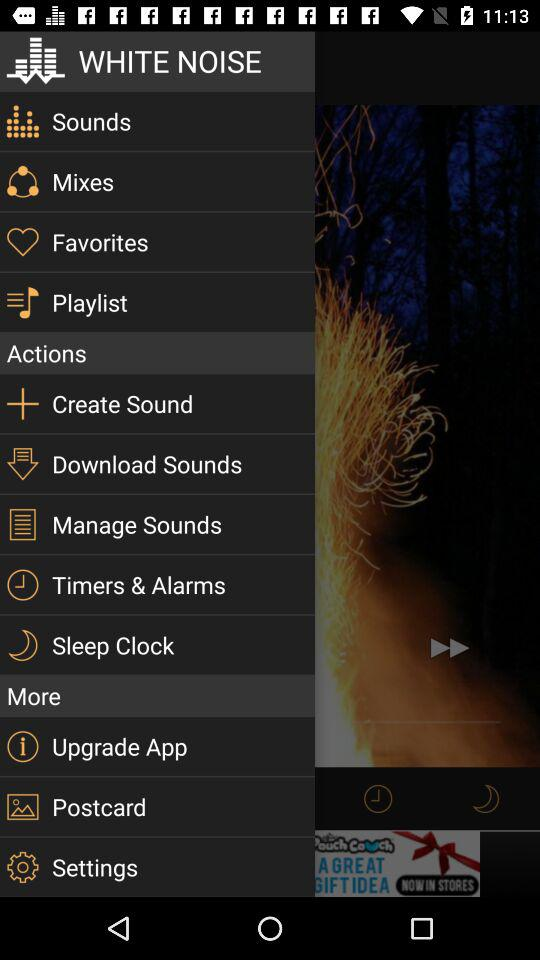What is the name of the application? The name of the application is "WHITE NOISE". 